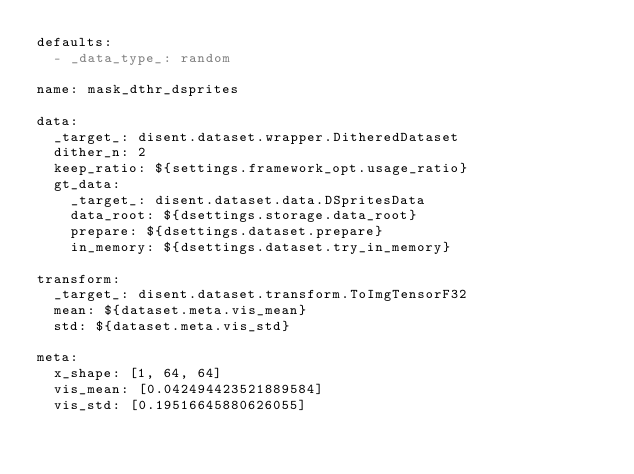Convert code to text. <code><loc_0><loc_0><loc_500><loc_500><_YAML_>defaults:
  - _data_type_: random

name: mask_dthr_dsprites

data:
  _target_: disent.dataset.wrapper.DitheredDataset
  dither_n: 2
  keep_ratio: ${settings.framework_opt.usage_ratio}
  gt_data:
    _target_: disent.dataset.data.DSpritesData
    data_root: ${dsettings.storage.data_root}
    prepare: ${dsettings.dataset.prepare}
    in_memory: ${dsettings.dataset.try_in_memory}

transform:
  _target_: disent.dataset.transform.ToImgTensorF32
  mean: ${dataset.meta.vis_mean}
  std: ${dataset.meta.vis_std}

meta:
  x_shape: [1, 64, 64]
  vis_mean: [0.042494423521889584]
  vis_std: [0.19516645880626055]
</code> 